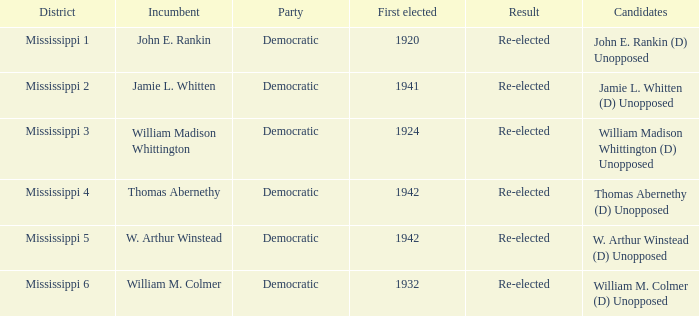What is the result for w. arthur winstead? Re-elected. Give me the full table as a dictionary. {'header': ['District', 'Incumbent', 'Party', 'First elected', 'Result', 'Candidates'], 'rows': [['Mississippi 1', 'John E. Rankin', 'Democratic', '1920', 'Re-elected', 'John E. Rankin (D) Unopposed'], ['Mississippi 2', 'Jamie L. Whitten', 'Democratic', '1941', 'Re-elected', 'Jamie L. Whitten (D) Unopposed'], ['Mississippi 3', 'William Madison Whittington', 'Democratic', '1924', 'Re-elected', 'William Madison Whittington (D) Unopposed'], ['Mississippi 4', 'Thomas Abernethy', 'Democratic', '1942', 'Re-elected', 'Thomas Abernethy (D) Unopposed'], ['Mississippi 5', 'W. Arthur Winstead', 'Democratic', '1942', 'Re-elected', 'W. Arthur Winstead (D) Unopposed'], ['Mississippi 6', 'William M. Colmer', 'Democratic', '1932', 'Re-elected', 'William M. Colmer (D) Unopposed']]} 